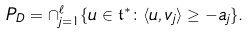<formula> <loc_0><loc_0><loc_500><loc_500>P _ { D } = \cap _ { j = 1 } ^ { \ell } \{ u \in \mathfrak t ^ { * } \colon \langle u , v _ { j } \rangle \geq - a _ { j } \} .</formula> 